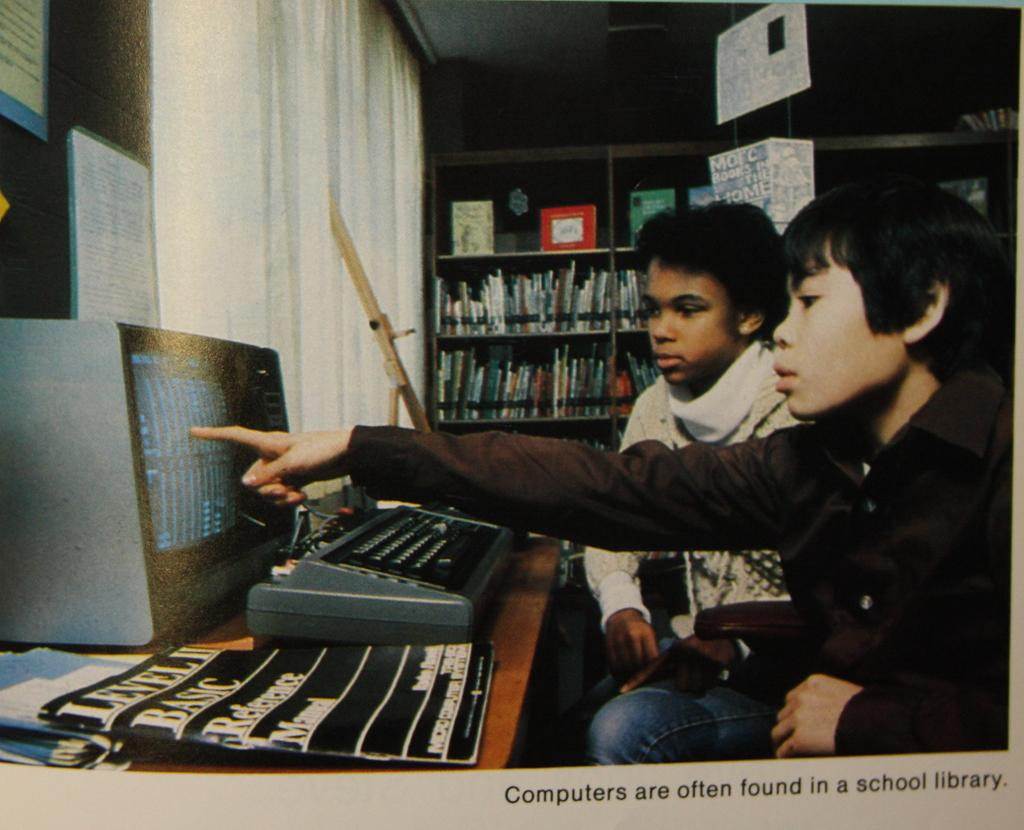<image>
Present a compact description of the photo's key features. Two young boys sit at a computer console with a copy of Level II Basic Reference Manual next to them. 